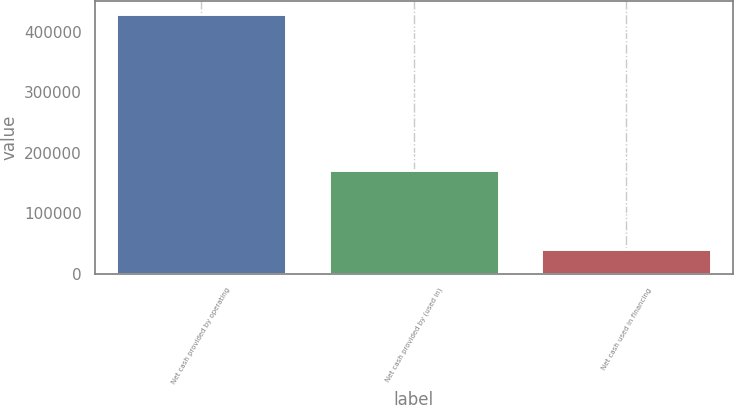<chart> <loc_0><loc_0><loc_500><loc_500><bar_chart><fcel>Net cash provided by operating<fcel>Net cash provided by (used in)<fcel>Net cash used in financing<nl><fcel>429506<fcel>171014<fcel>41834<nl></chart> 